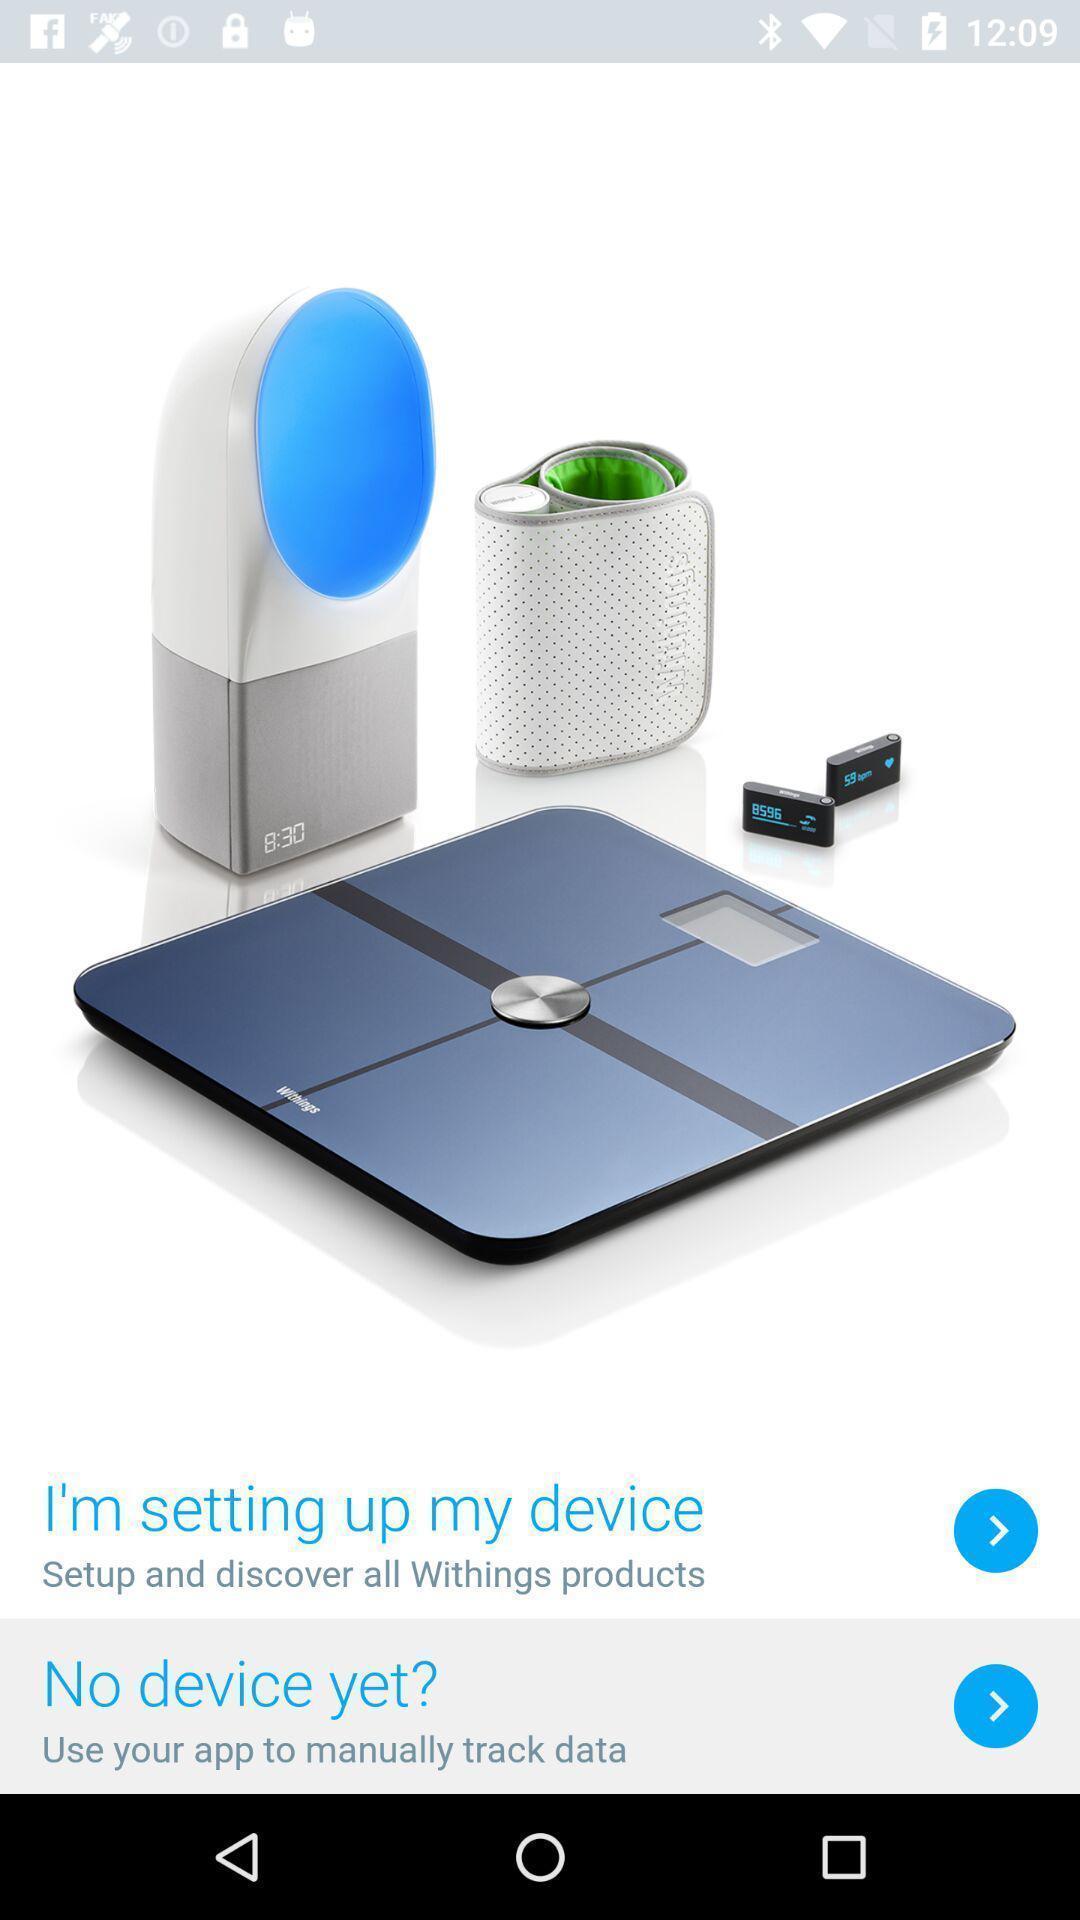Describe the key features of this screenshot. Setup page of a device. 